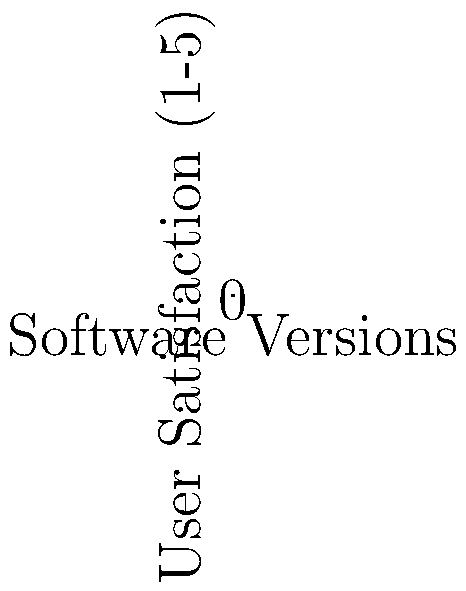Based on the graph comparing user satisfaction ratings for open-source and proprietary software across five versions, what conclusion can be drawn about the user interfaces of these two types of software that would be most relevant to an elderly user who values user-friendliness? To answer this question, we need to analyze the graph and interpret it from the perspective of an elderly user who values user-friendliness. Let's break it down step-by-step:

1. Understand the graph:
   - The x-axis represents different software versions (1 to 5).
   - The y-axis represents user satisfaction on a scale of 1 to 5.
   - Blue line represents open-source software.
   - Red line represents proprietary software.

2. Compare the trends:
   - Open-source software (blue line) shows an overall upward trend in user satisfaction.
   - Proprietary software (red line) also shows an upward trend, but consistently lower than open-source.

3. Analyze the gap between the two lines:
   - The gap between open-source and proprietary software widens slightly over time.
   - By version 5, open-source software has a satisfaction rating of 5, while proprietary is at 4.

4. Consider the elderly user's perspective:
   - They value user-friendliness and prefer more user-friendly software.
   - Higher user satisfaction often correlates with better user-friendliness.

5. Interpret the results:
   - The consistently higher ratings for open-source software suggest that its user interface may have become more user-friendly over time.
   - The widening gap implies that open-source software might be adapting more quickly to user needs.

6. Draw a conclusion:
   - For an elderly user valuing user-friendliness, the open-source software appears to be the better choice based on the higher and improving user satisfaction ratings.
Answer: Open-source software shows higher and improving user satisfaction, suggesting better user-friendliness for elderly users. 